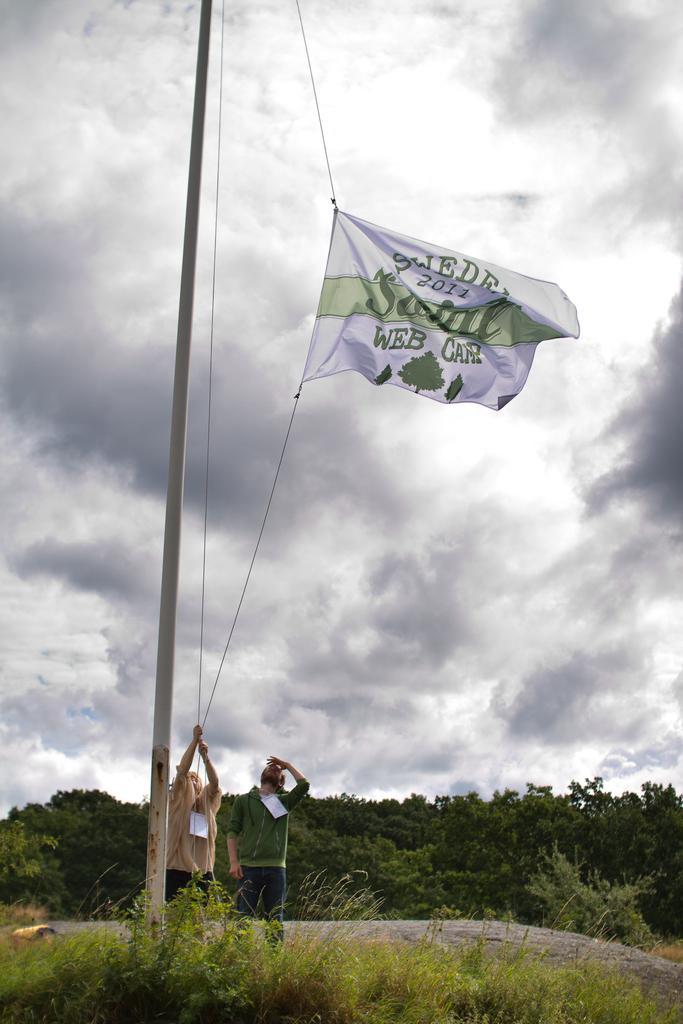Describe this image in one or two sentences. In this image, there are two persons standing. Among them one person is hoisting a flag. At the bottom of the image, I can see the trees and plants. In the background, there is the sky. 